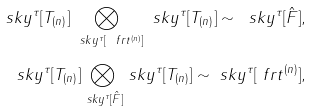Convert formula to latex. <formula><loc_0><loc_0><loc_500><loc_500>\ s k y ^ { \tau } [ T _ { ( n ) } ] \underset { \ s k y ^ { \tau } [ \ f r t ^ { ( n ) } ] } \bigotimes \ s k y ^ { \tau } [ T _ { ( n ) } ] \sim \ s k y ^ { \tau } [ \hat { F } ] , \\ \ s k y ^ { \tau } [ T _ { ( n ) } ] \underset { \ s k y ^ { \tau } [ \hat { F } ] } \bigotimes \ s k y ^ { \tau } [ T _ { ( n ) } ] \sim \ s k y ^ { \tau } [ \ f r t ^ { ( n ) } ] ,</formula> 